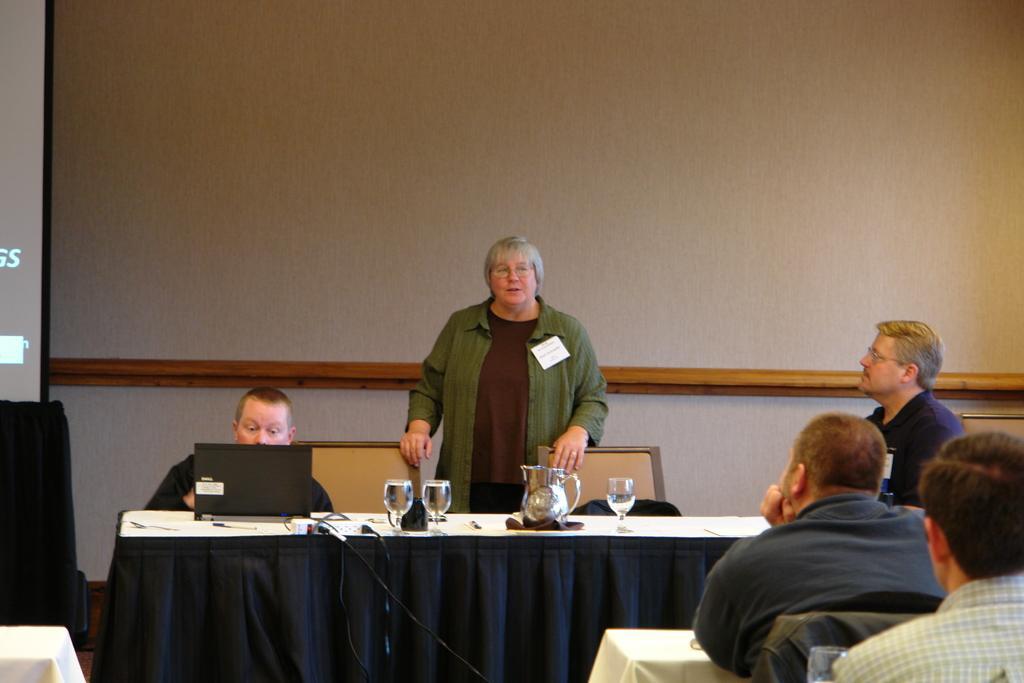Can you describe this image briefly? In this picture we can see person standing and talking and aside to this person one man is sitting and looking at laptop and other person looking at her and in front of them there is table and on table we can see glasses, jar, wires and in background we can see wall. 